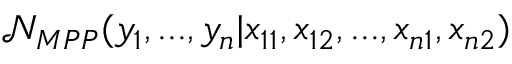<formula> <loc_0><loc_0><loc_500><loc_500>\mathcal { N } _ { M P P } ( y _ { 1 } , \dots , y _ { n } | x _ { 1 1 } , x _ { 1 2 } , \dots , x _ { n 1 } , x _ { n 2 } )</formula> 